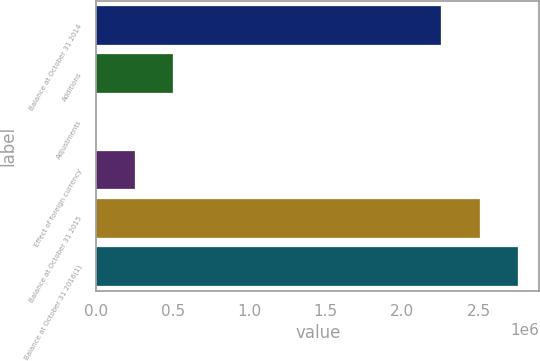<chart> <loc_0><loc_0><loc_500><loc_500><bar_chart><fcel>Balance at October 31 2014<fcel>Additions<fcel>Adjustments<fcel>Effect of foreign currency<fcel>Balance at October 31 2015<fcel>Balance at October 31 2016(1)<nl><fcel>2.25571e+06<fcel>504196<fcel>684<fcel>252440<fcel>2.50746e+06<fcel>2.75922e+06<nl></chart> 